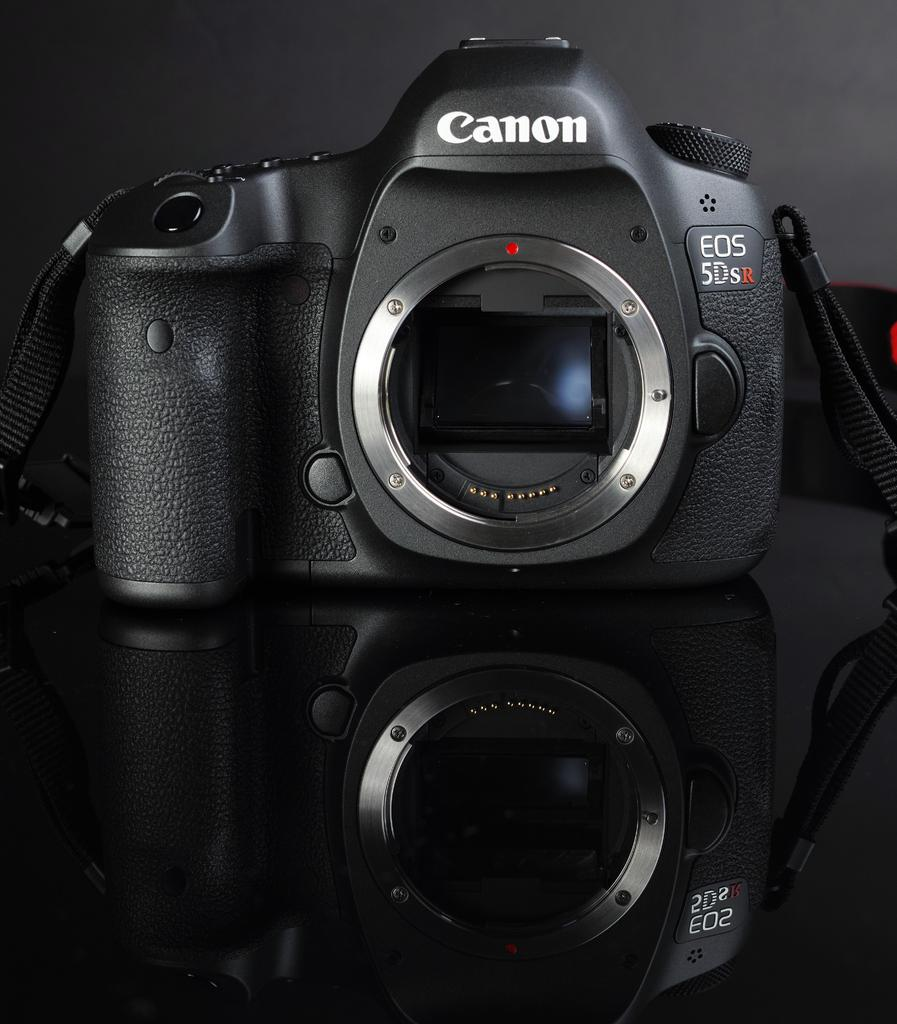<image>
Relay a brief, clear account of the picture shown. A Canon camera sits on a black shiny table 